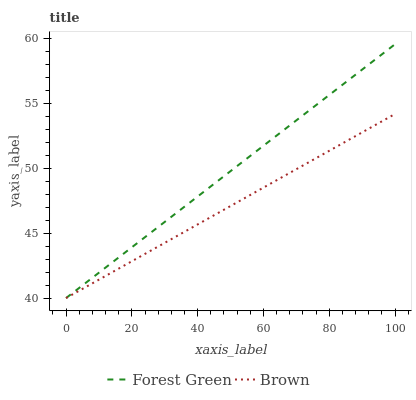Does Forest Green have the minimum area under the curve?
Answer yes or no. No. Is Forest Green the smoothest?
Answer yes or no. No. 